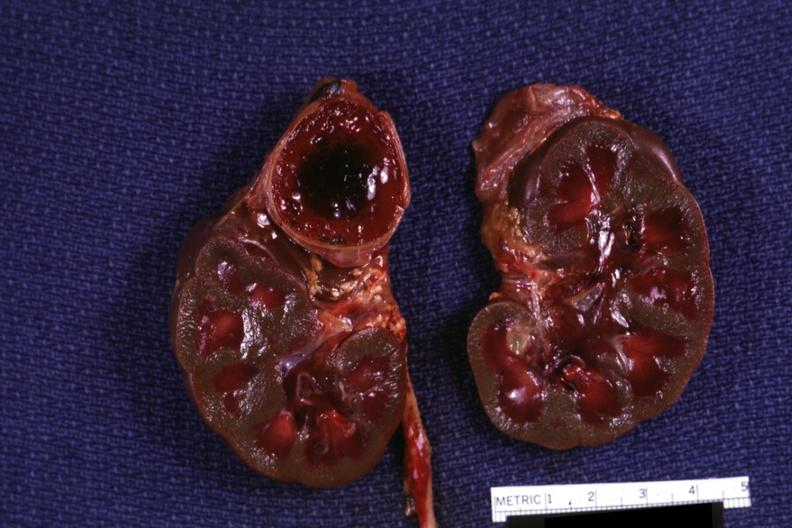how many side do section of both kidneys and adrenals hemorrhage on kidneys are jaundiced?
Answer the question using a single word or phrase. One 